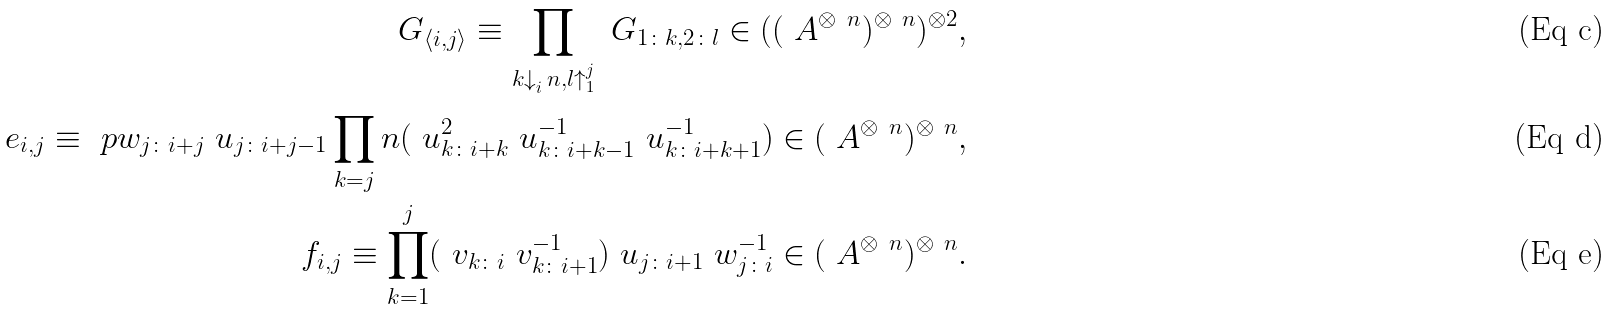Convert formula to latex. <formula><loc_0><loc_0><loc_500><loc_500>\ G _ { \langle i , j \rangle } \equiv \prod _ { k \downarrow _ { i } ^ { \ } n , l \uparrow _ { 1 } ^ { j } } \ G _ { 1 \colon k , 2 \colon l } \in ( ( \ A ^ { \otimes \ n } ) ^ { \otimes \ n } ) ^ { \otimes 2 } , \\ \ e _ { i , j } \equiv \ p w _ { j \colon i + j } \ u _ { j \colon i + j - 1 } \prod _ { k = j } ^ { \ } n ( \ u _ { k \colon i + k } ^ { 2 } \ u _ { k \colon i + k - 1 } ^ { - 1 } \ u _ { k \colon i + k + 1 } ^ { - 1 } ) \in ( \ A ^ { \otimes \ n } ) ^ { \otimes \ n } , \\ \ f _ { i , j } \equiv \prod _ { k = 1 } ^ { j } ( \ v _ { k \colon i } \ v _ { k \colon i + 1 } ^ { - 1 } ) \ u _ { j \colon i + 1 } \ w _ { j \colon i } ^ { - 1 } \in ( \ A ^ { \otimes \ n } ) ^ { \otimes \ n } .</formula> 